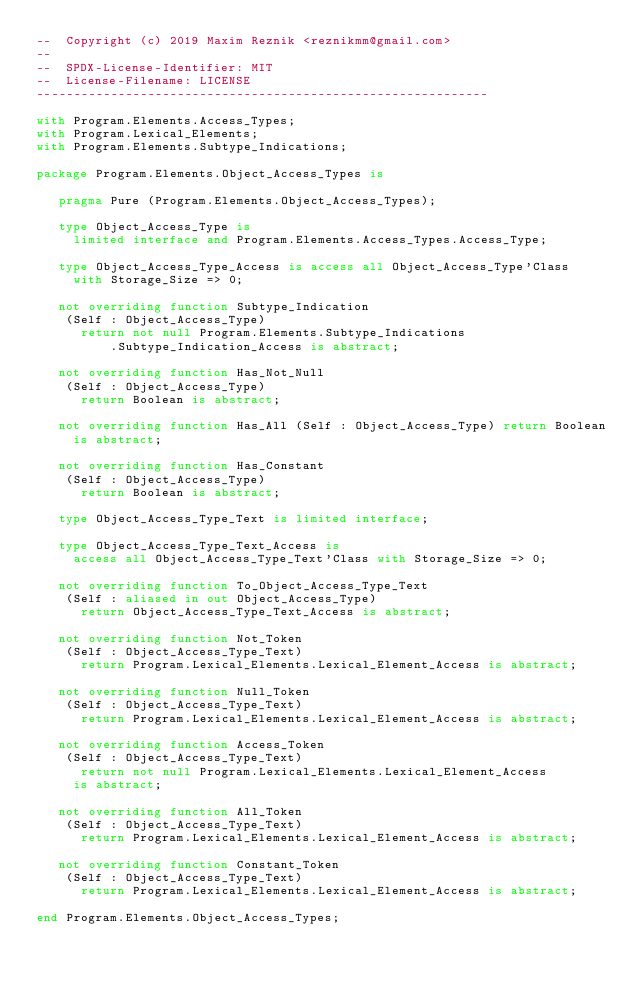<code> <loc_0><loc_0><loc_500><loc_500><_Ada_>--  Copyright (c) 2019 Maxim Reznik <reznikmm@gmail.com>
--
--  SPDX-License-Identifier: MIT
--  License-Filename: LICENSE
-------------------------------------------------------------

with Program.Elements.Access_Types;
with Program.Lexical_Elements;
with Program.Elements.Subtype_Indications;

package Program.Elements.Object_Access_Types is

   pragma Pure (Program.Elements.Object_Access_Types);

   type Object_Access_Type is
     limited interface and Program.Elements.Access_Types.Access_Type;

   type Object_Access_Type_Access is access all Object_Access_Type'Class
     with Storage_Size => 0;

   not overriding function Subtype_Indication
    (Self : Object_Access_Type)
      return not null Program.Elements.Subtype_Indications
          .Subtype_Indication_Access is abstract;

   not overriding function Has_Not_Null
    (Self : Object_Access_Type)
      return Boolean is abstract;

   not overriding function Has_All (Self : Object_Access_Type) return Boolean
     is abstract;

   not overriding function Has_Constant
    (Self : Object_Access_Type)
      return Boolean is abstract;

   type Object_Access_Type_Text is limited interface;

   type Object_Access_Type_Text_Access is
     access all Object_Access_Type_Text'Class with Storage_Size => 0;

   not overriding function To_Object_Access_Type_Text
    (Self : aliased in out Object_Access_Type)
      return Object_Access_Type_Text_Access is abstract;

   not overriding function Not_Token
    (Self : Object_Access_Type_Text)
      return Program.Lexical_Elements.Lexical_Element_Access is abstract;

   not overriding function Null_Token
    (Self : Object_Access_Type_Text)
      return Program.Lexical_Elements.Lexical_Element_Access is abstract;

   not overriding function Access_Token
    (Self : Object_Access_Type_Text)
      return not null Program.Lexical_Elements.Lexical_Element_Access
     is abstract;

   not overriding function All_Token
    (Self : Object_Access_Type_Text)
      return Program.Lexical_Elements.Lexical_Element_Access is abstract;

   not overriding function Constant_Token
    (Self : Object_Access_Type_Text)
      return Program.Lexical_Elements.Lexical_Element_Access is abstract;

end Program.Elements.Object_Access_Types;
</code> 